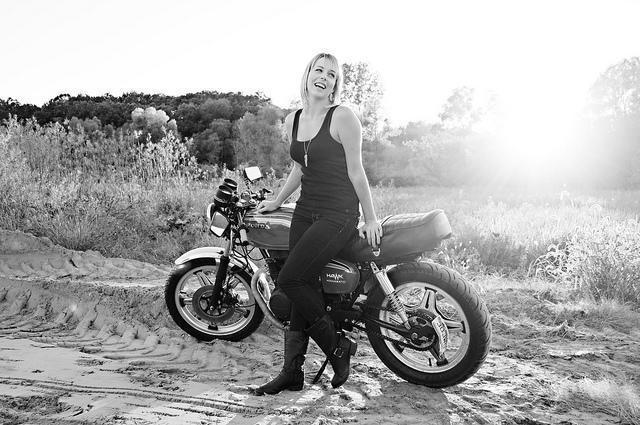How many cups are there?
Give a very brief answer. 0. 